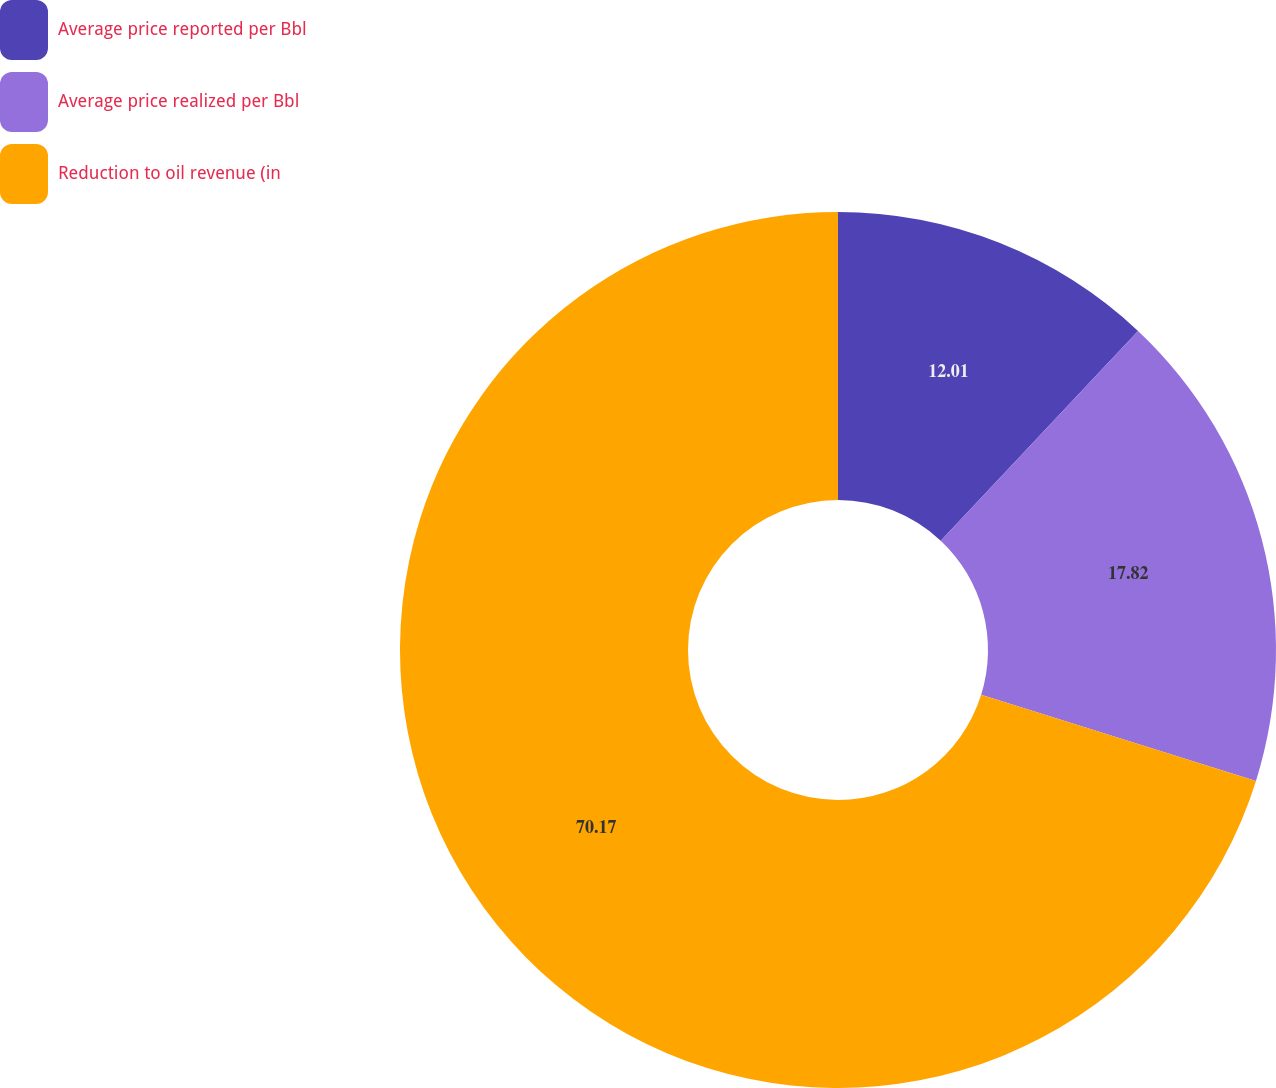Convert chart. <chart><loc_0><loc_0><loc_500><loc_500><pie_chart><fcel>Average price reported per Bbl<fcel>Average price realized per Bbl<fcel>Reduction to oil revenue (in<nl><fcel>12.01%<fcel>17.82%<fcel>70.17%<nl></chart> 